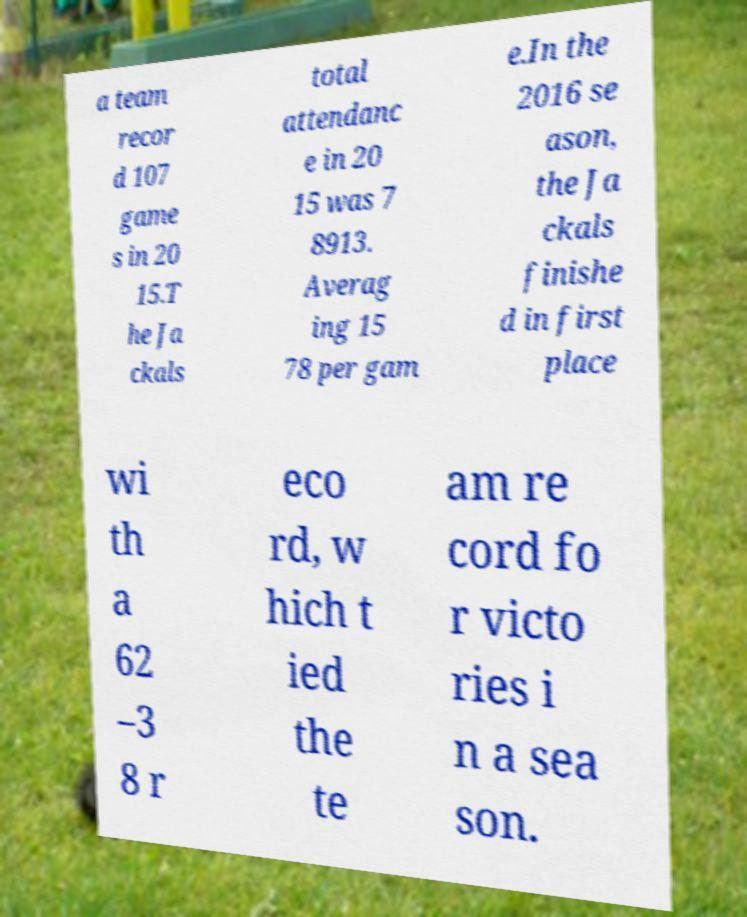For documentation purposes, I need the text within this image transcribed. Could you provide that? a team recor d 107 game s in 20 15.T he Ja ckals total attendanc e in 20 15 was 7 8913. Averag ing 15 78 per gam e.In the 2016 se ason, the Ja ckals finishe d in first place wi th a 62 –3 8 r eco rd, w hich t ied the te am re cord fo r victo ries i n a sea son. 